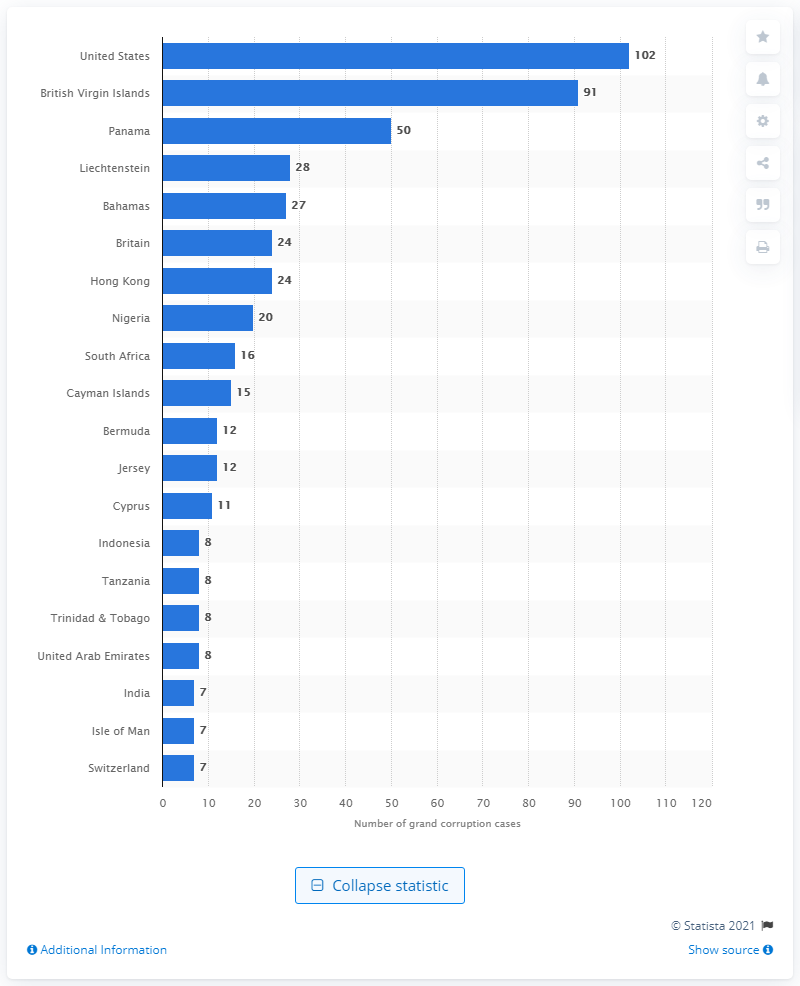Indicate a few pertinent items in this graphic. Between 1980 and 2010, at least 15 cases of grand corruption took place on the Cayman Islands. 